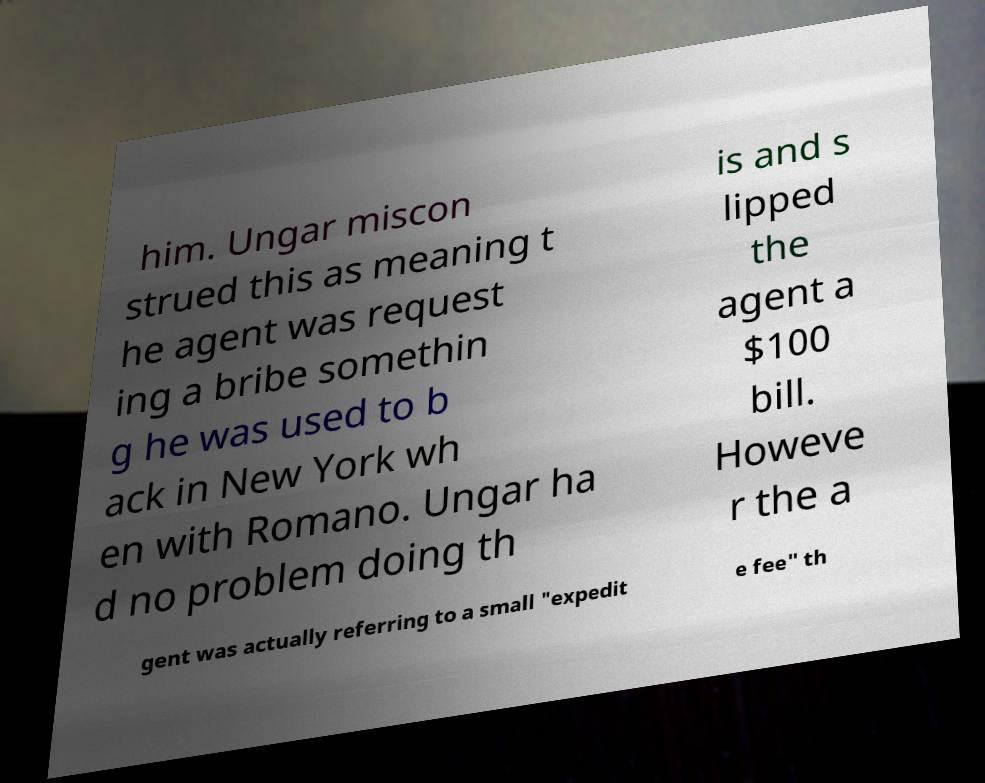Can you accurately transcribe the text from the provided image for me? him. Ungar miscon strued this as meaning t he agent was request ing a bribe somethin g he was used to b ack in New York wh en with Romano. Ungar ha d no problem doing th is and s lipped the agent a $100 bill. Howeve r the a gent was actually referring to a small "expedit e fee" th 